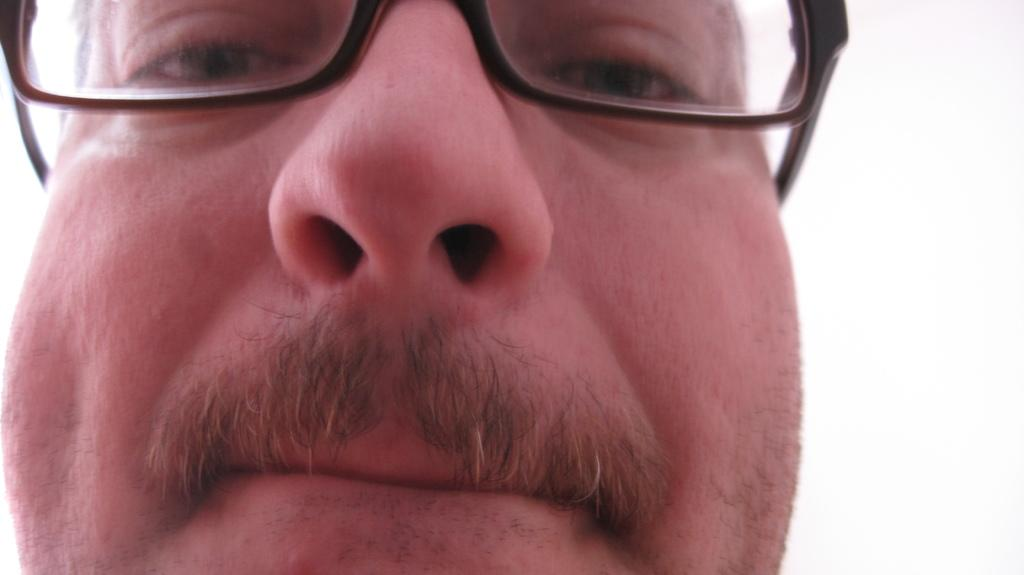What is the main subject of the image? There is a person in the image. Can you describe the person's appearance? The person is wearing spectacles. What is the color of the background in the image? The background of the image is white. How many frogs are on the person's team in the image? There are no frogs or teams present in the image; it features a person wearing spectacles against a white background. 